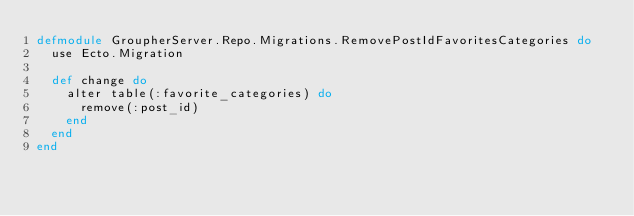Convert code to text. <code><loc_0><loc_0><loc_500><loc_500><_Elixir_>defmodule GroupherServer.Repo.Migrations.RemovePostIdFavoritesCategories do
  use Ecto.Migration

  def change do
    alter table(:favorite_categories) do
      remove(:post_id)
    end
  end
end
</code> 